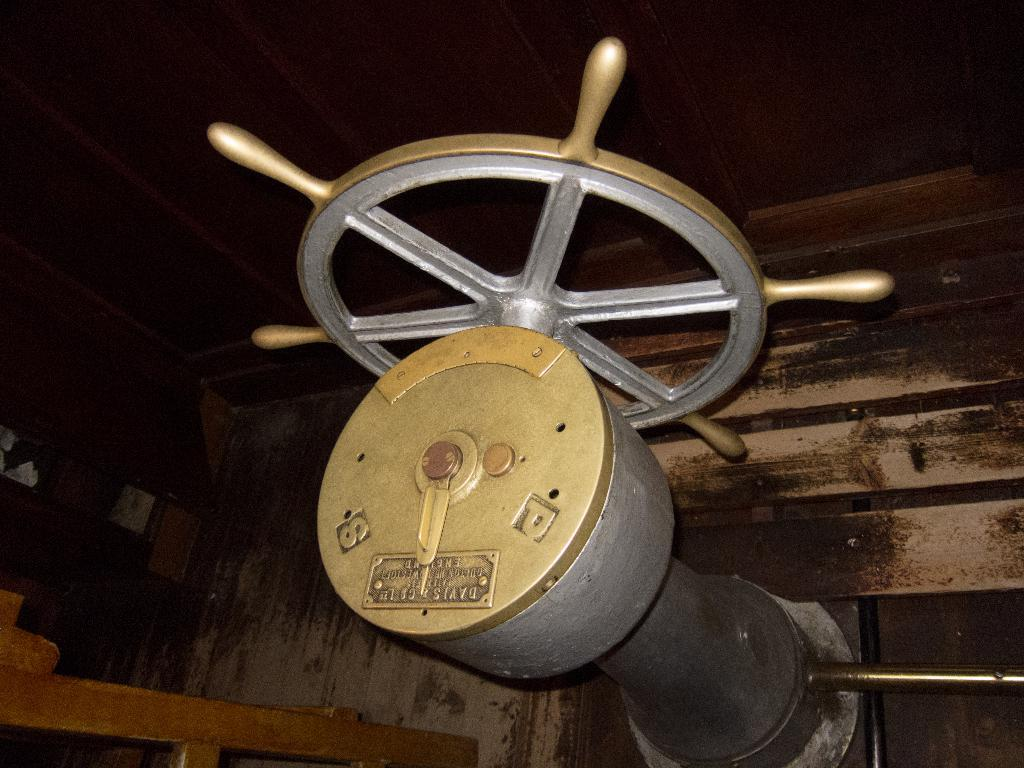What object is the main focus of the image? The main focus of the image is a ship steering wheel. What might this object be used for? The ship steering wheel is used for navigating and controlling the direction of a ship. Can you describe the appearance of the steering wheel? The image shows a ship steering wheel with spokes and a circular shape. What type of stomach is visible in the image? There is no stomach present in the image; it features a ship steering wheel. What kind of structure is depicted in the image, other than the ship steering wheel? There is no other structure depicted in the image besides the ship steering wheel. 